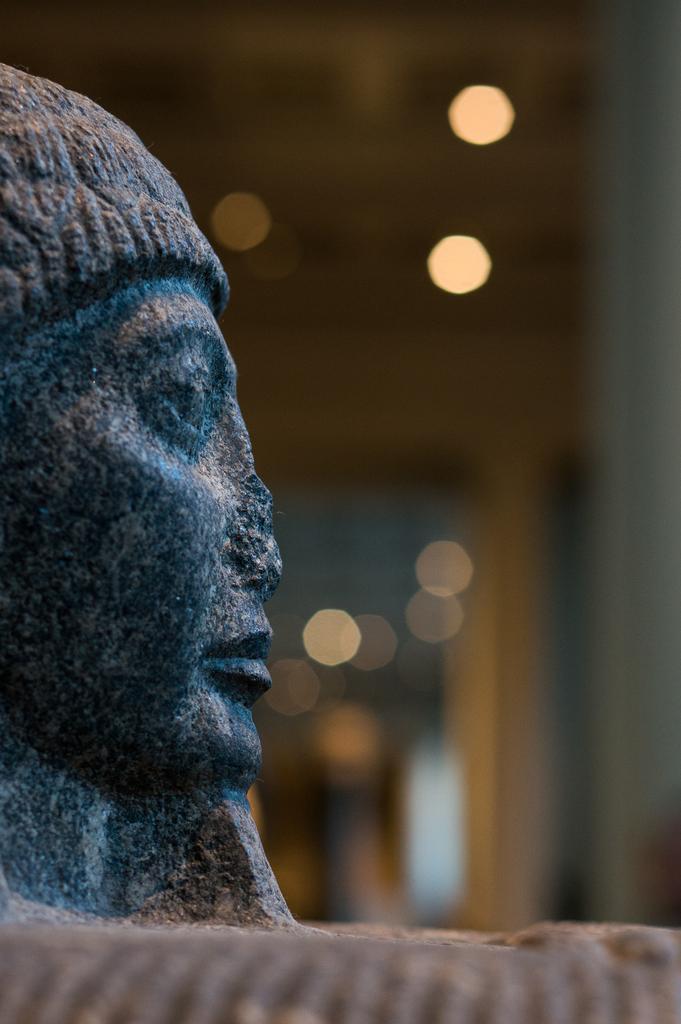Can you describe this image briefly? On the left side of this image there is a sculpture. The background is blurred. 